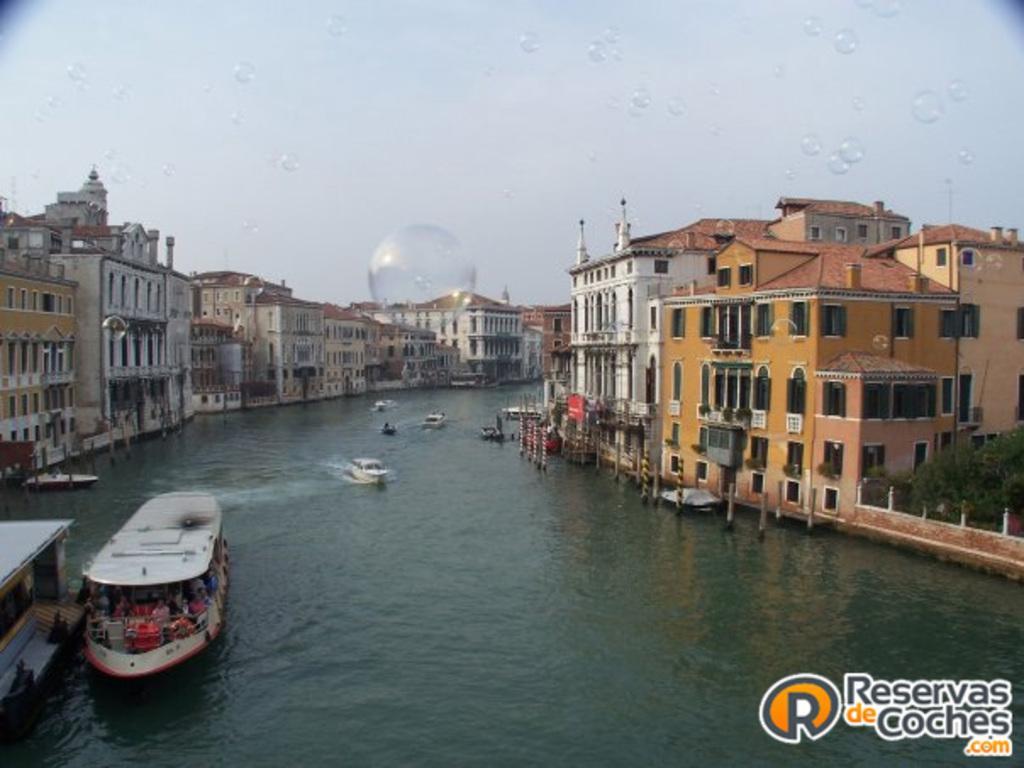Please provide a concise description of this image. The image is taken from some website, the website is mentioned at the right side bottom. There is a river and many boats and ships are moving on the river, there are a lot of buildings and apartments around the river, there are many bubbles flying in the air. 